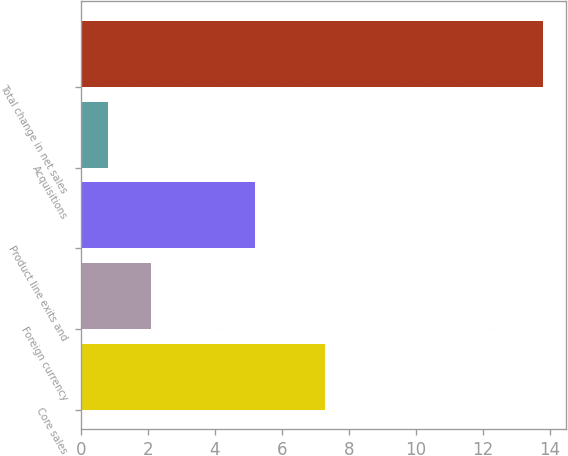Convert chart to OTSL. <chart><loc_0><loc_0><loc_500><loc_500><bar_chart><fcel>Core sales<fcel>Foreign currency<fcel>Product line exits and<fcel>Acquisitions<fcel>Total change in net sales<nl><fcel>7.3<fcel>2.1<fcel>5.2<fcel>0.8<fcel>13.8<nl></chart> 